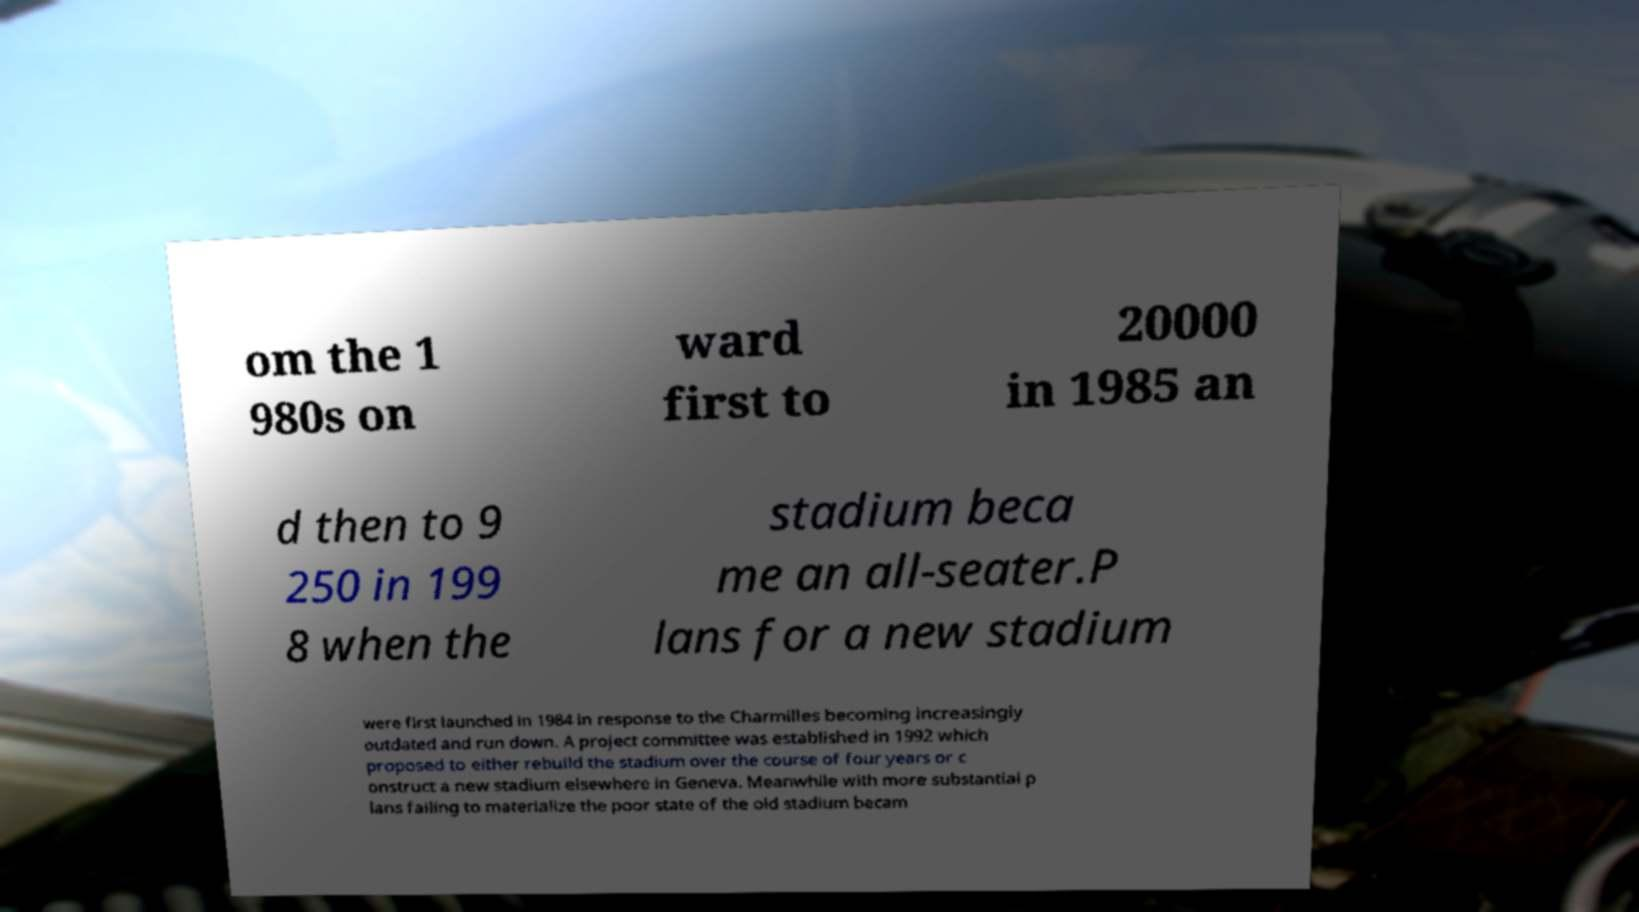Can you read and provide the text displayed in the image?This photo seems to have some interesting text. Can you extract and type it out for me? om the 1 980s on ward first to 20000 in 1985 an d then to 9 250 in 199 8 when the stadium beca me an all-seater.P lans for a new stadium were first launched in 1984 in response to the Charmilles becoming increasingly outdated and run down. A project committee was established in 1992 which proposed to either rebuild the stadium over the course of four years or c onstruct a new stadium elsewhere in Geneva. Meanwhile with more substantial p lans failing to materialize the poor state of the old stadium becam 